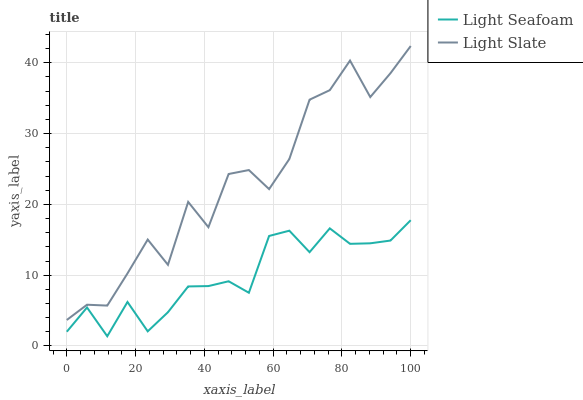Does Light Seafoam have the minimum area under the curve?
Answer yes or no. Yes. Does Light Slate have the maximum area under the curve?
Answer yes or no. Yes. Does Light Seafoam have the maximum area under the curve?
Answer yes or no. No. Is Light Seafoam the smoothest?
Answer yes or no. Yes. Is Light Slate the roughest?
Answer yes or no. Yes. Is Light Seafoam the roughest?
Answer yes or no. No. Does Light Seafoam have the lowest value?
Answer yes or no. Yes. Does Light Slate have the highest value?
Answer yes or no. Yes. Does Light Seafoam have the highest value?
Answer yes or no. No. Is Light Seafoam less than Light Slate?
Answer yes or no. Yes. Is Light Slate greater than Light Seafoam?
Answer yes or no. Yes. Does Light Seafoam intersect Light Slate?
Answer yes or no. No. 